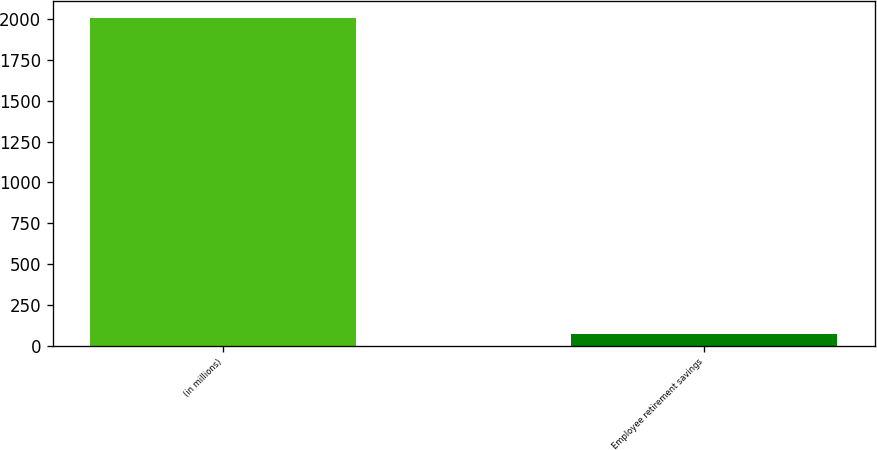<chart> <loc_0><loc_0><loc_500><loc_500><bar_chart><fcel>(in millions)<fcel>Employee retirement savings<nl><fcel>2009<fcel>72.4<nl></chart> 